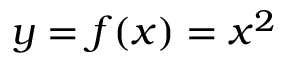<formula> <loc_0><loc_0><loc_500><loc_500>y = f ( x ) = x ^ { 2 }</formula> 